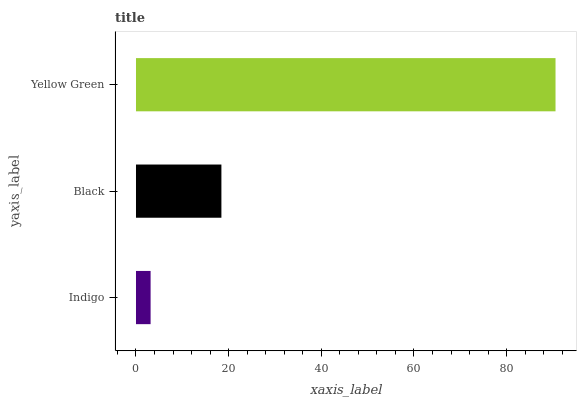Is Indigo the minimum?
Answer yes or no. Yes. Is Yellow Green the maximum?
Answer yes or no. Yes. Is Black the minimum?
Answer yes or no. No. Is Black the maximum?
Answer yes or no. No. Is Black greater than Indigo?
Answer yes or no. Yes. Is Indigo less than Black?
Answer yes or no. Yes. Is Indigo greater than Black?
Answer yes or no. No. Is Black less than Indigo?
Answer yes or no. No. Is Black the high median?
Answer yes or no. Yes. Is Black the low median?
Answer yes or no. Yes. Is Yellow Green the high median?
Answer yes or no. No. Is Indigo the low median?
Answer yes or no. No. 